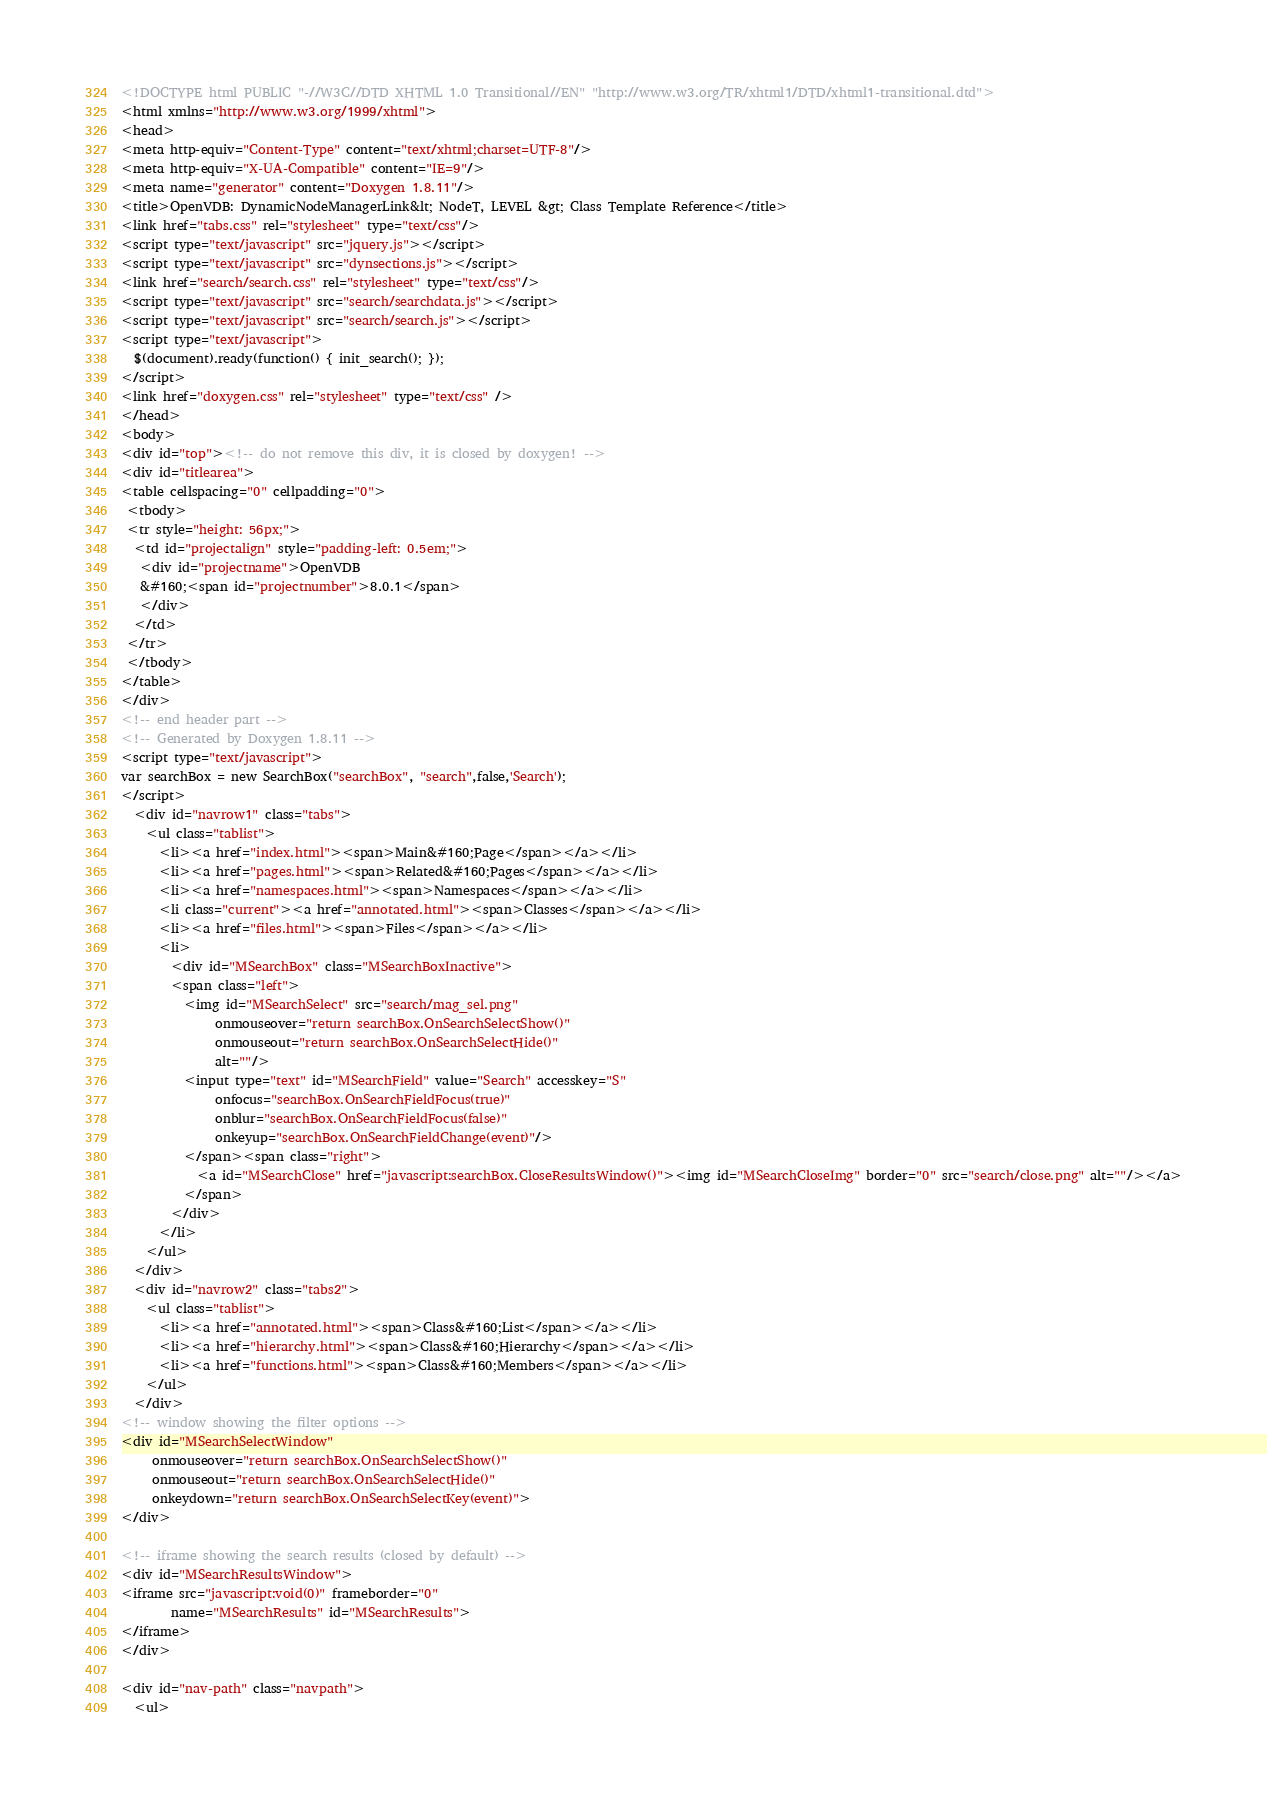<code> <loc_0><loc_0><loc_500><loc_500><_HTML_><!DOCTYPE html PUBLIC "-//W3C//DTD XHTML 1.0 Transitional//EN" "http://www.w3.org/TR/xhtml1/DTD/xhtml1-transitional.dtd">
<html xmlns="http://www.w3.org/1999/xhtml">
<head>
<meta http-equiv="Content-Type" content="text/xhtml;charset=UTF-8"/>
<meta http-equiv="X-UA-Compatible" content="IE=9"/>
<meta name="generator" content="Doxygen 1.8.11"/>
<title>OpenVDB: DynamicNodeManagerLink&lt; NodeT, LEVEL &gt; Class Template Reference</title>
<link href="tabs.css" rel="stylesheet" type="text/css"/>
<script type="text/javascript" src="jquery.js"></script>
<script type="text/javascript" src="dynsections.js"></script>
<link href="search/search.css" rel="stylesheet" type="text/css"/>
<script type="text/javascript" src="search/searchdata.js"></script>
<script type="text/javascript" src="search/search.js"></script>
<script type="text/javascript">
  $(document).ready(function() { init_search(); });
</script>
<link href="doxygen.css" rel="stylesheet" type="text/css" />
</head>
<body>
<div id="top"><!-- do not remove this div, it is closed by doxygen! -->
<div id="titlearea">
<table cellspacing="0" cellpadding="0">
 <tbody>
 <tr style="height: 56px;">
  <td id="projectalign" style="padding-left: 0.5em;">
   <div id="projectname">OpenVDB
   &#160;<span id="projectnumber">8.0.1</span>
   </div>
  </td>
 </tr>
 </tbody>
</table>
</div>
<!-- end header part -->
<!-- Generated by Doxygen 1.8.11 -->
<script type="text/javascript">
var searchBox = new SearchBox("searchBox", "search",false,'Search');
</script>
  <div id="navrow1" class="tabs">
    <ul class="tablist">
      <li><a href="index.html"><span>Main&#160;Page</span></a></li>
      <li><a href="pages.html"><span>Related&#160;Pages</span></a></li>
      <li><a href="namespaces.html"><span>Namespaces</span></a></li>
      <li class="current"><a href="annotated.html"><span>Classes</span></a></li>
      <li><a href="files.html"><span>Files</span></a></li>
      <li>
        <div id="MSearchBox" class="MSearchBoxInactive">
        <span class="left">
          <img id="MSearchSelect" src="search/mag_sel.png"
               onmouseover="return searchBox.OnSearchSelectShow()"
               onmouseout="return searchBox.OnSearchSelectHide()"
               alt=""/>
          <input type="text" id="MSearchField" value="Search" accesskey="S"
               onfocus="searchBox.OnSearchFieldFocus(true)" 
               onblur="searchBox.OnSearchFieldFocus(false)" 
               onkeyup="searchBox.OnSearchFieldChange(event)"/>
          </span><span class="right">
            <a id="MSearchClose" href="javascript:searchBox.CloseResultsWindow()"><img id="MSearchCloseImg" border="0" src="search/close.png" alt=""/></a>
          </span>
        </div>
      </li>
    </ul>
  </div>
  <div id="navrow2" class="tabs2">
    <ul class="tablist">
      <li><a href="annotated.html"><span>Class&#160;List</span></a></li>
      <li><a href="hierarchy.html"><span>Class&#160;Hierarchy</span></a></li>
      <li><a href="functions.html"><span>Class&#160;Members</span></a></li>
    </ul>
  </div>
<!-- window showing the filter options -->
<div id="MSearchSelectWindow"
     onmouseover="return searchBox.OnSearchSelectShow()"
     onmouseout="return searchBox.OnSearchSelectHide()"
     onkeydown="return searchBox.OnSearchSelectKey(event)">
</div>

<!-- iframe showing the search results (closed by default) -->
<div id="MSearchResultsWindow">
<iframe src="javascript:void(0)" frameborder="0" 
        name="MSearchResults" id="MSearchResults">
</iframe>
</div>

<div id="nav-path" class="navpath">
  <ul></code> 